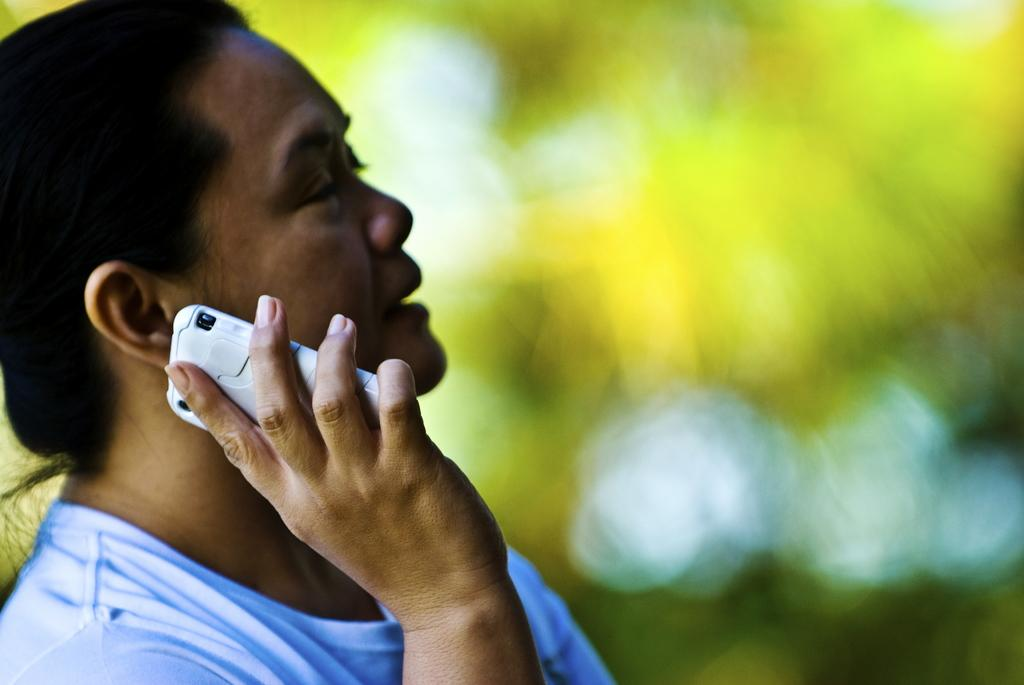What is the main subject of the image? The main subject of the image is a man. What is the man doing in the image? The man is sitting in the image. What object is the man holding in his hands? The man is holding a mobile in his hands. What is the man wearing in the image? The man is wearing a white t-shirt. Can you see any potatoes in the image? There are no potatoes present in the image. Is the man using a nail to interact with the mobile in the image? There is no nail visible in the image, and the man is not using a nail to interact with the mobile. --- Facts: 1. There is a car in the image. 2. The car is red. 3. The car has four wheels. 4. There is a road in the background of the image. 5. The sky is visible in the image. Absurd Topics: parrot, sandcastle, umbrella Conversation: What is the main subject of the image? The main subject of the image is a car. What color is the car in the image? The car is red. How many wheels does the car have? The car has four wheels. What is visible in the background of the image? There is a road in the background of the image. What is visible at the top of the image? The sky is visible at the top of the image. Reasoning: Let's think step by step in order to produce the conversation. We start by identifying the main subject of the image, which is the car. Then, we describe the car's color and the number of wheels it has. Next, we observe the background of the image, noting the presence of a road. Finally, we describe the sky's condition, which is visible in the image. Absurd Question/Answer: Can you see a parrot sitting on the car's roof in the image? There is no parrot present on the car's roof in the image. Is there a sandcastle being built on the side of the road in the image? There is no sandcastle being built on the side of the road in the image. 